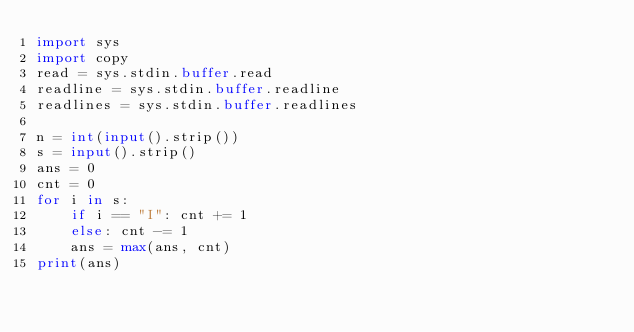Convert code to text. <code><loc_0><loc_0><loc_500><loc_500><_Python_>import sys
import copy
read = sys.stdin.buffer.read
readline = sys.stdin.buffer.readline
readlines = sys.stdin.buffer.readlines

n = int(input().strip())
s = input().strip()
ans = 0
cnt = 0
for i in s:
    if i == "I": cnt += 1 
    else: cnt -= 1
    ans = max(ans, cnt)
print(ans)
</code> 